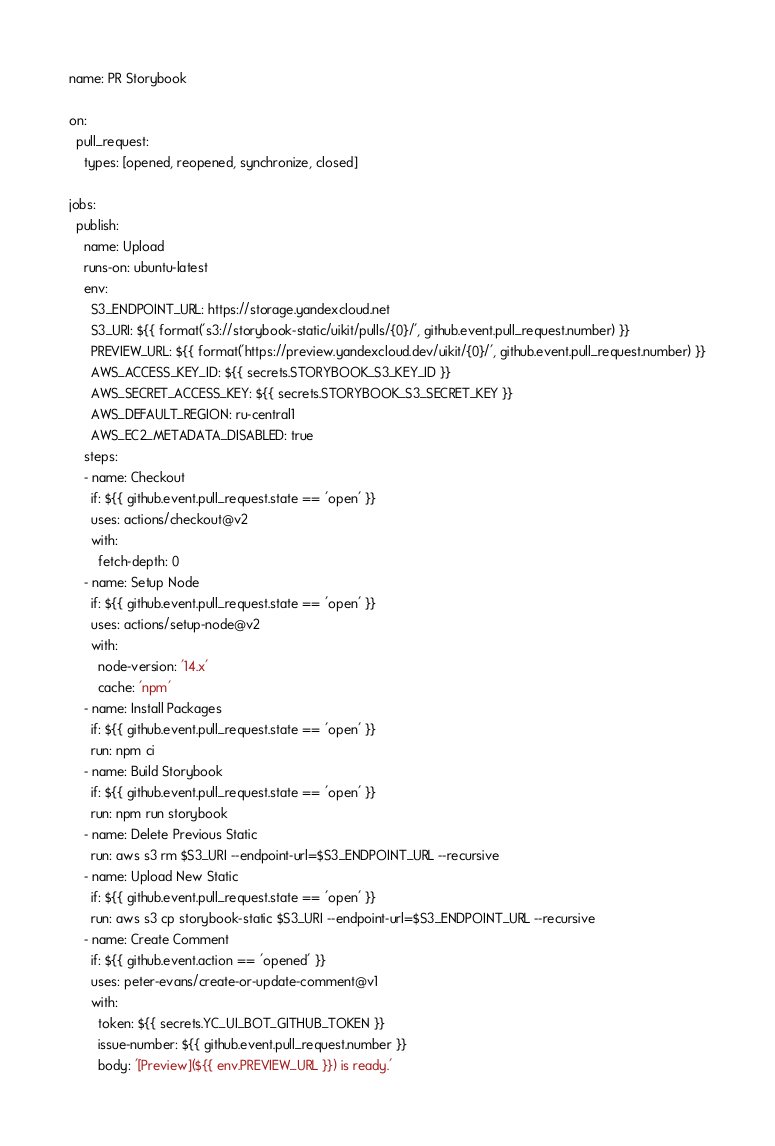Convert code to text. <code><loc_0><loc_0><loc_500><loc_500><_YAML_>name: PR Storybook

on:
  pull_request:
    types: [opened, reopened, synchronize, closed]

jobs:
  publish:
    name: Upload
    runs-on: ubuntu-latest
    env:
      S3_ENDPOINT_URL: https://storage.yandexcloud.net
      S3_URI: ${{ format('s3://storybook-static/uikit/pulls/{0}/', github.event.pull_request.number) }}
      PREVIEW_URL: ${{ format('https://preview.yandexcloud.dev/uikit/{0}/', github.event.pull_request.number) }}
      AWS_ACCESS_KEY_ID: ${{ secrets.STORYBOOK_S3_KEY_ID }}
      AWS_SECRET_ACCESS_KEY: ${{ secrets.STORYBOOK_S3_SECRET_KEY }}
      AWS_DEFAULT_REGION: ru-central1
      AWS_EC2_METADATA_DISABLED: true
    steps:
    - name: Checkout
      if: ${{ github.event.pull_request.state == 'open' }}
      uses: actions/checkout@v2
      with:
        fetch-depth: 0
    - name: Setup Node
      if: ${{ github.event.pull_request.state == 'open' }}
      uses: actions/setup-node@v2
      with:
        node-version: '14.x'
        cache: 'npm'
    - name: Install Packages
      if: ${{ github.event.pull_request.state == 'open' }}
      run: npm ci
    - name: Build Storybook
      if: ${{ github.event.pull_request.state == 'open' }}
      run: npm run storybook
    - name: Delete Previous Static
      run: aws s3 rm $S3_URI --endpoint-url=$S3_ENDPOINT_URL --recursive
    - name: Upload New Static
      if: ${{ github.event.pull_request.state == 'open' }}
      run: aws s3 cp storybook-static $S3_URI --endpoint-url=$S3_ENDPOINT_URL --recursive
    - name: Create Comment
      if: ${{ github.event.action == 'opened' }}
      uses: peter-evans/create-or-update-comment@v1
      with:
        token: ${{ secrets.YC_UI_BOT_GITHUB_TOKEN }}
        issue-number: ${{ github.event.pull_request.number }}
        body: '[Preview](${{ env.PREVIEW_URL }}) is ready.'
</code> 